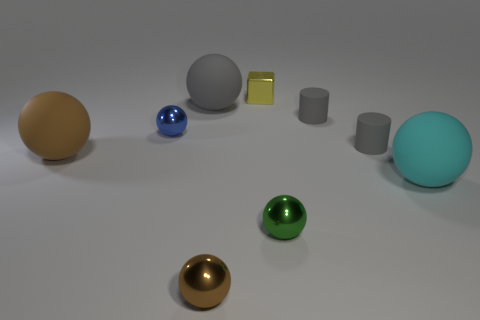How many gray cylinders must be subtracted to get 1 gray cylinders? 1 Add 1 small green balls. How many objects exist? 10 Subtract all big cyan rubber balls. How many balls are left? 5 Subtract 1 blocks. How many blocks are left? 0 Subtract all purple cylinders. Subtract all blue blocks. How many cylinders are left? 2 Subtract all red cylinders. How many red cubes are left? 0 Subtract all green spheres. Subtract all shiny things. How many objects are left? 4 Add 3 cyan matte balls. How many cyan matte balls are left? 4 Add 1 blue objects. How many blue objects exist? 2 Subtract all blue spheres. How many spheres are left? 5 